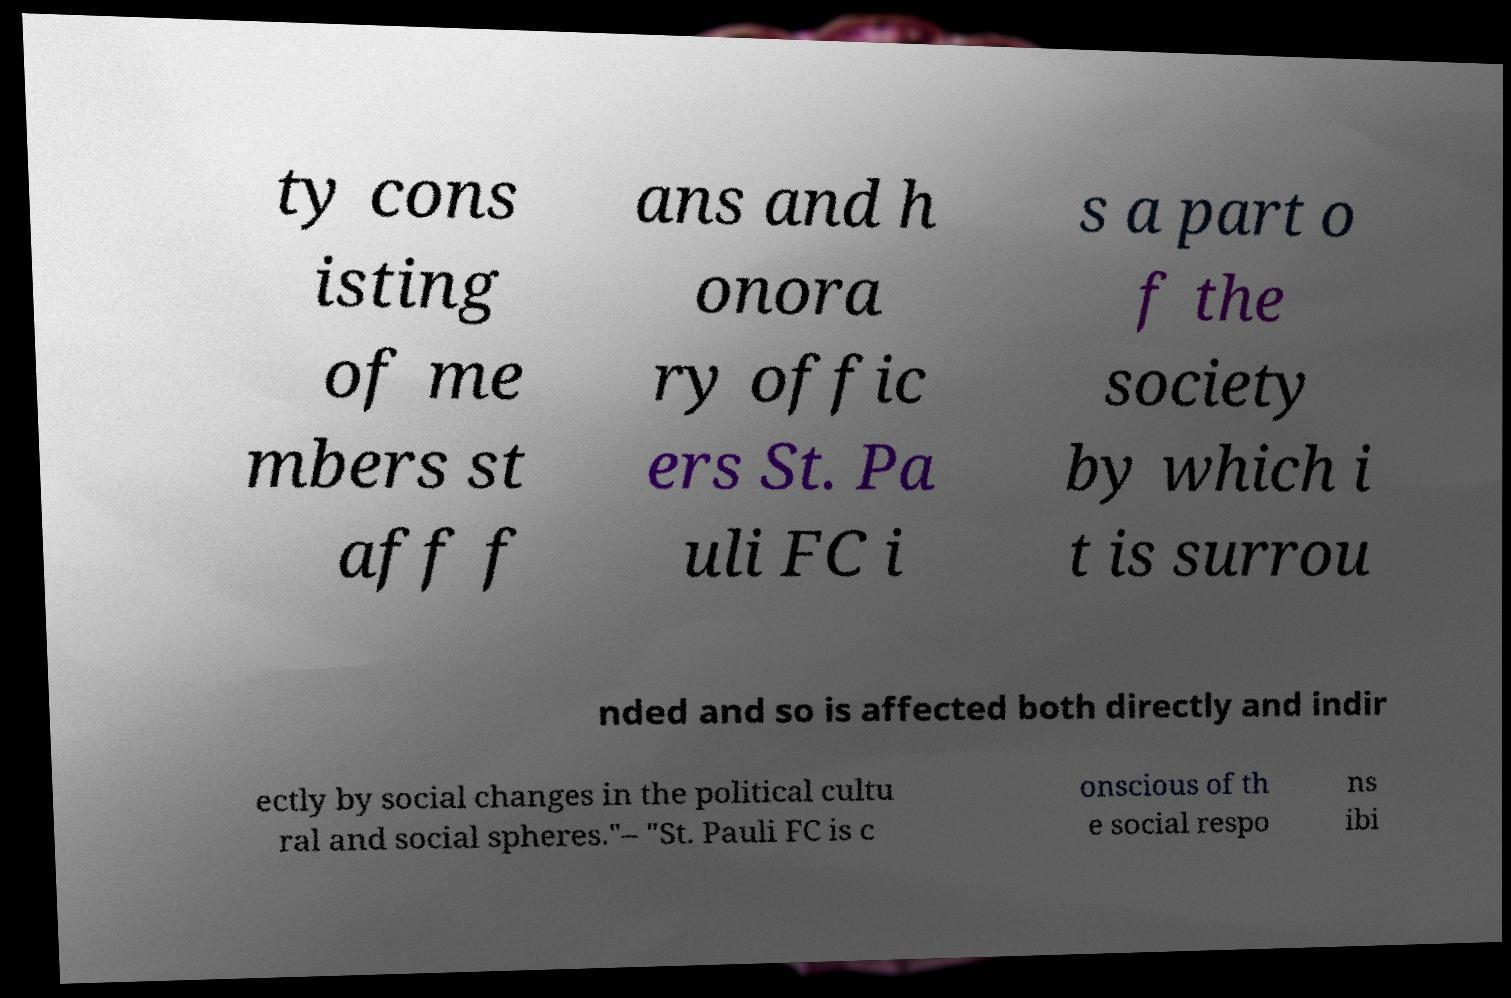Could you assist in decoding the text presented in this image and type it out clearly? ty cons isting of me mbers st aff f ans and h onora ry offic ers St. Pa uli FC i s a part o f the society by which i t is surrou nded and so is affected both directly and indir ectly by social changes in the political cultu ral and social spheres."– "St. Pauli FC is c onscious of th e social respo ns ibi 